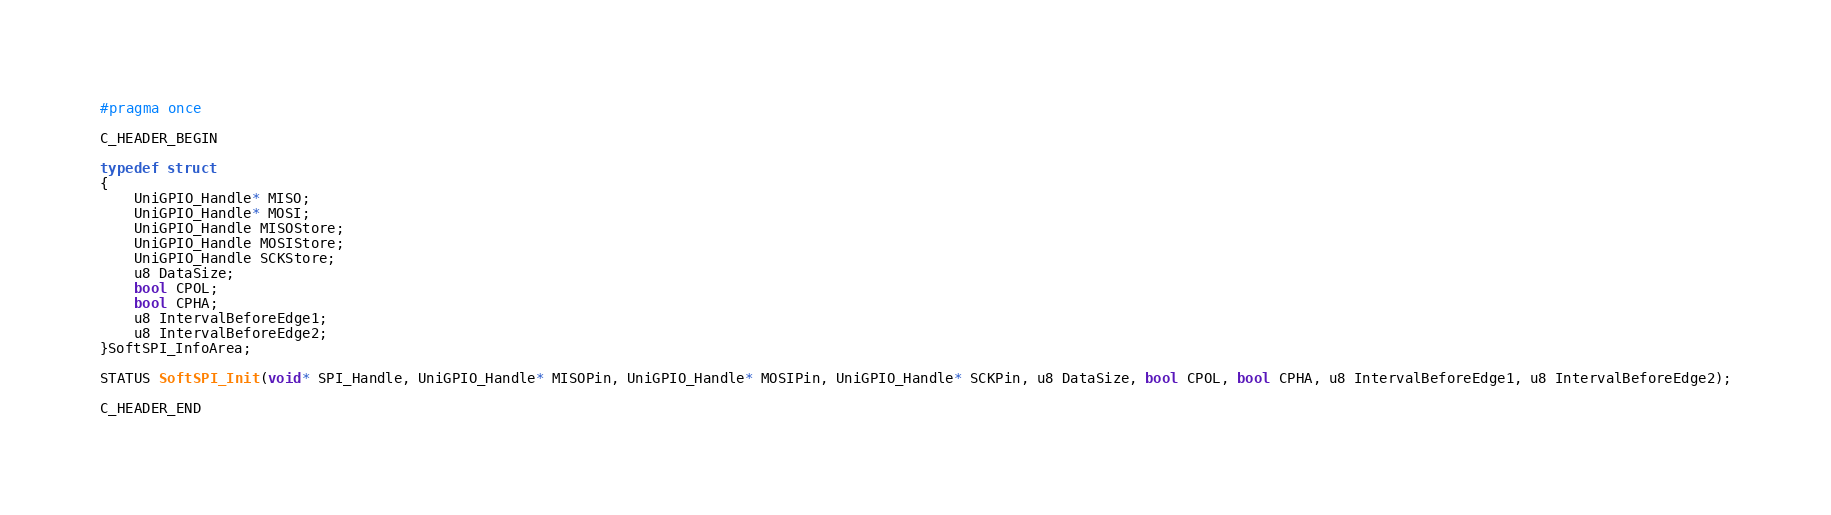<code> <loc_0><loc_0><loc_500><loc_500><_C_>#pragma once

C_HEADER_BEGIN

typedef struct
{
	UniGPIO_Handle* MISO;
	UniGPIO_Handle* MOSI;
	UniGPIO_Handle MISOStore;
	UniGPIO_Handle MOSIStore;
	UniGPIO_Handle SCKStore;
	u8 DataSize;
	bool CPOL;
	bool CPHA;
	u8 IntervalBeforeEdge1;
	u8 IntervalBeforeEdge2;
}SoftSPI_InfoArea;

STATUS SoftSPI_Init(void* SPI_Handle, UniGPIO_Handle* MISOPin, UniGPIO_Handle* MOSIPin, UniGPIO_Handle* SCKPin, u8 DataSize, bool CPOL, bool CPHA, u8 IntervalBeforeEdge1, u8 IntervalBeforeEdge2);

C_HEADER_END
</code> 